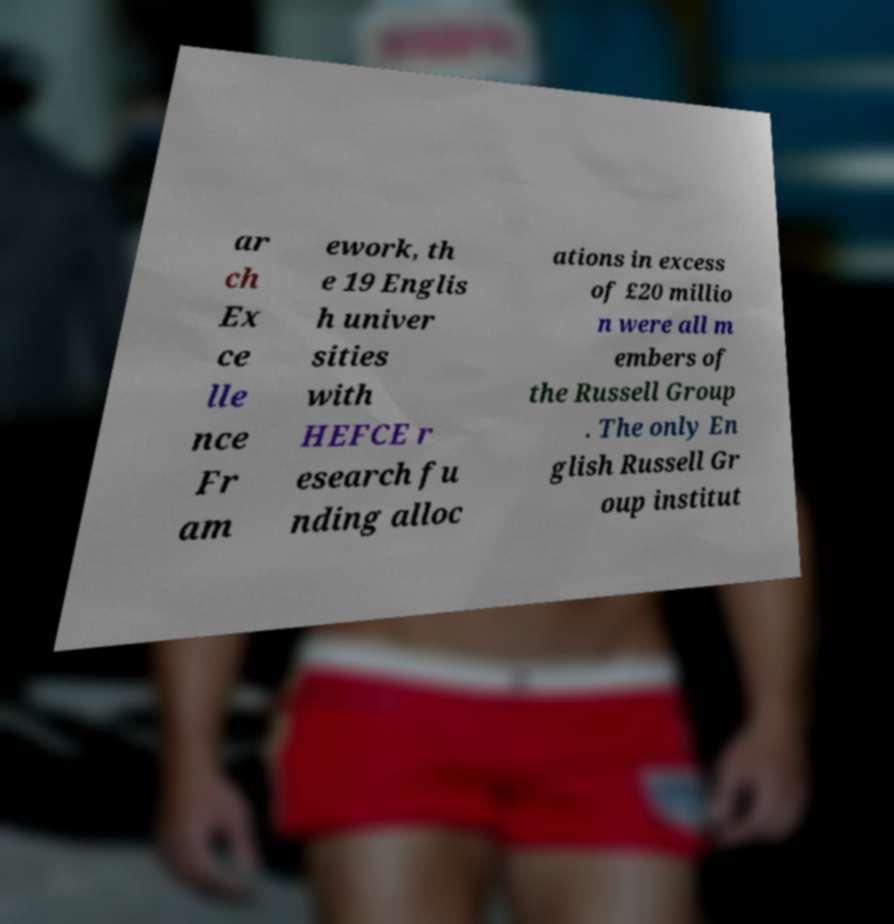For documentation purposes, I need the text within this image transcribed. Could you provide that? ar ch Ex ce lle nce Fr am ework, th e 19 Englis h univer sities with HEFCE r esearch fu nding alloc ations in excess of £20 millio n were all m embers of the Russell Group . The only En glish Russell Gr oup institut 